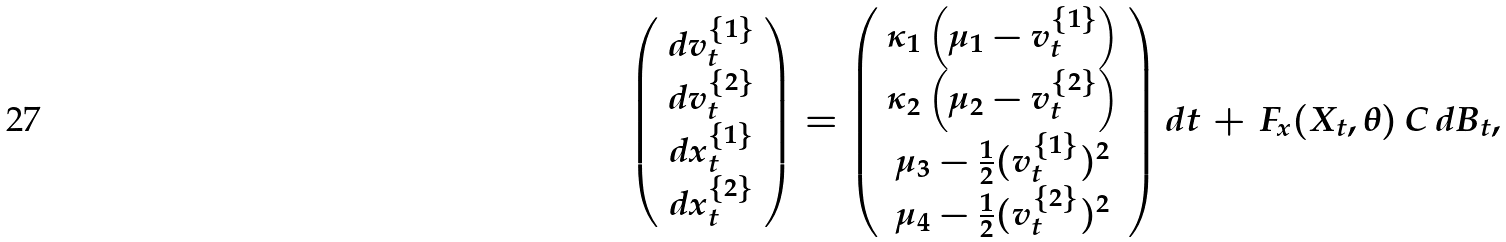<formula> <loc_0><loc_0><loc_500><loc_500>\left ( \begin{array} { c c c } d v _ { t } ^ { \{ 1 \} } \\ d v _ { t } ^ { \{ 2 \} } \\ d x _ { t } ^ { \{ 1 \} } \\ d x _ { t } ^ { \{ 2 \} } \end{array} \right ) = \left ( \begin{array} { c c c } \kappa _ { 1 } \left ( \mu _ { 1 } - v _ { t } ^ { \{ 1 \} } \right ) \\ \kappa _ { 2 } \left ( \mu _ { 2 } - v _ { t } ^ { \{ 2 \} } \right ) \\ \mu _ { 3 } - \frac { 1 } { 2 } ( v _ { t } ^ { \{ 1 \} } ) ^ { 2 } \\ \mu _ { 4 } - \frac { 1 } { 2 } ( v _ { t } ^ { \{ 2 \} } ) ^ { 2 } \end{array} \right ) d t \, + \, F _ { x } ( X _ { t } , \theta ) \, C \, d B _ { t } ,</formula> 